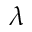Convert formula to latex. <formula><loc_0><loc_0><loc_500><loc_500>\lambda</formula> 